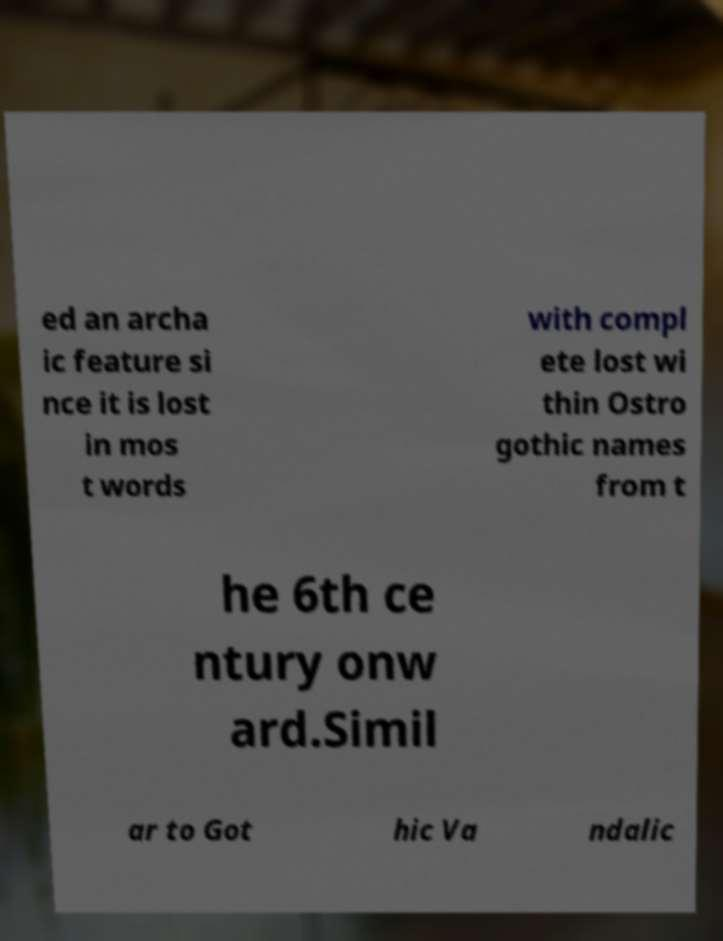Can you accurately transcribe the text from the provided image for me? ed an archa ic feature si nce it is lost in mos t words with compl ete lost wi thin Ostro gothic names from t he 6th ce ntury onw ard.Simil ar to Got hic Va ndalic 